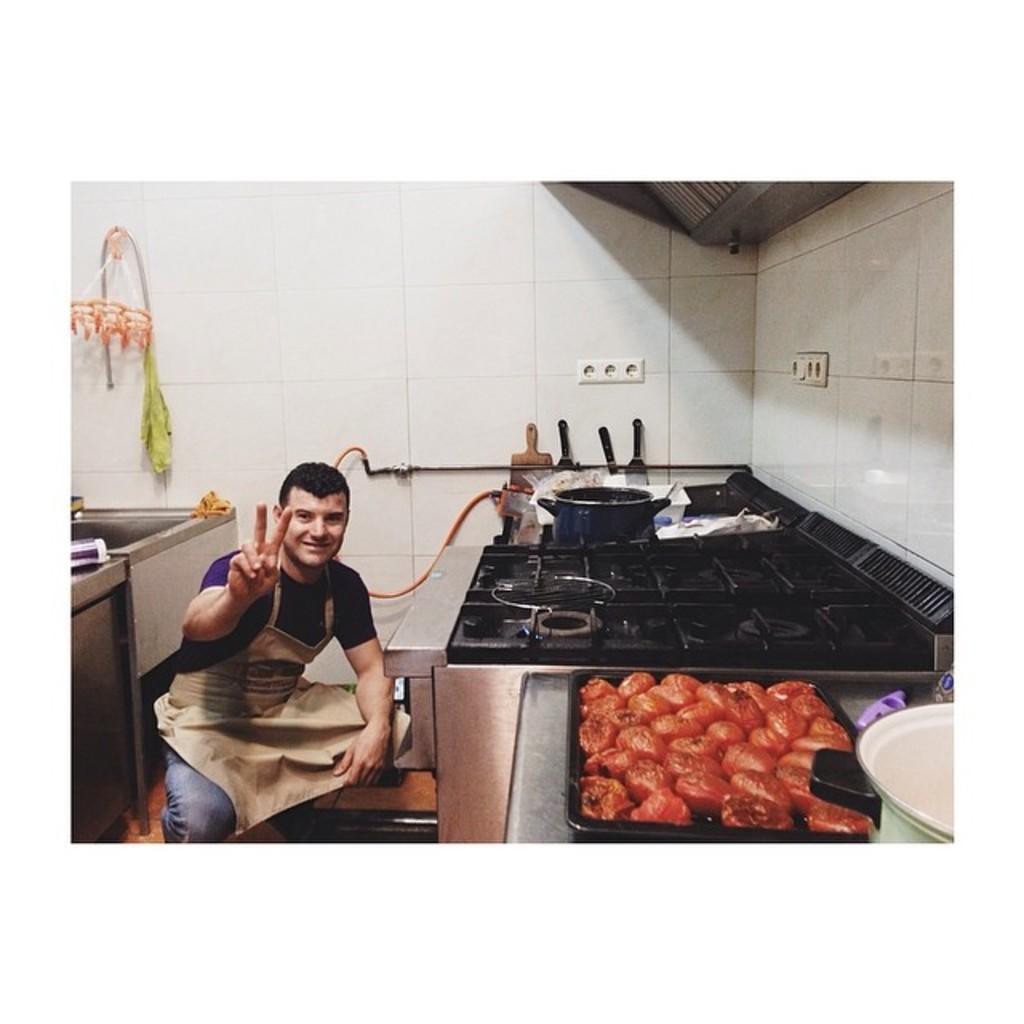Could you give a brief overview of what you see in this image? The man in the middle of the picture wearing purple T-shirt and apron is sitting on the chair. He is posing for the photo. He is smiling. In front of him, we see gas stove. Beside that, we see a counter top on which vessels, a bowl containing eatables and a bowl are placed. Behind him, we see a white wall. 